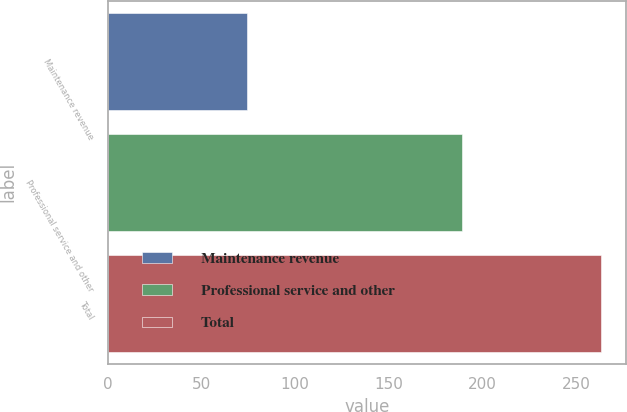Convert chart. <chart><loc_0><loc_0><loc_500><loc_500><bar_chart><fcel>Maintenance revenue<fcel>Professional service and other<fcel>Total<nl><fcel>74.4<fcel>189.1<fcel>263.5<nl></chart> 